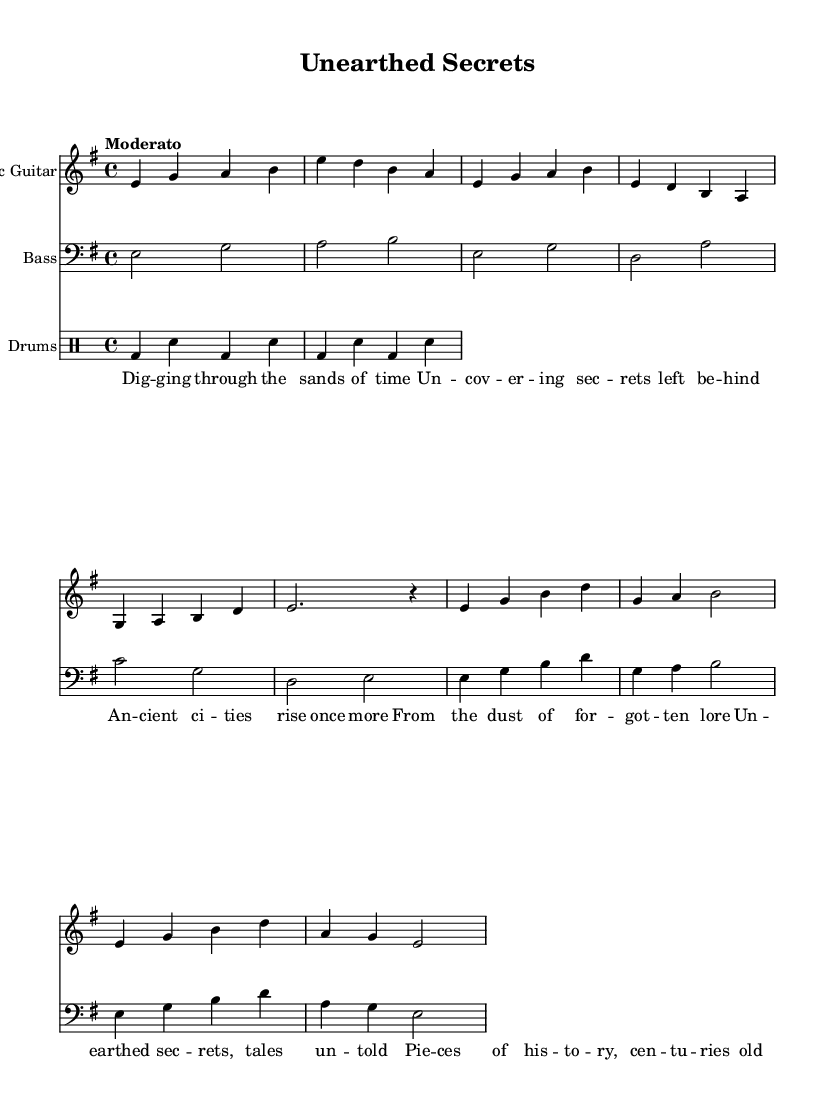What is the key signature of this music? The key signature is indicated at the beginning of the score, which shows one sharp, indicating that the music is in E minor.
Answer: E minor What is the time signature of this music? The time signature is shown next to the key signature at the beginning and is written as 4/4, meaning there are four beats in a measure.
Answer: 4/4 What is the tempo marking of this music? The tempo marking appears above the staff and indicates a moderate speed of performance, shown as "Moderato".
Answer: Moderato How many measures are in the verse section? The verse section consists of two distinct groupings of two measures each, totaling four measures overall.
Answer: 4 What instruments are featured in this score? The score lists three distinct instruments: Electric Guitar, Bass, and Drums, each represented with its own staff.
Answer: Electric Guitar, Bass, Drums What is the lyrical theme of the song based on the lyrics provided? The lyrics suggest a theme centered around archaeology, exploration, and uncovering ancient secrets from the past.
Answer: Archaeological exploration What is the structure of the song as suggested by the sections? The song displays a clear structural division with sections labeled as Intro, Verse, and Chorus, suggesting a popular song format.
Answer: Intro, Verse, Chorus 